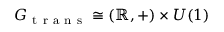Convert formula to latex. <formula><loc_0><loc_0><loc_500><loc_500>G _ { t r a n s } \cong ( \mathbb { R } , + ) \times U ( 1 )</formula> 